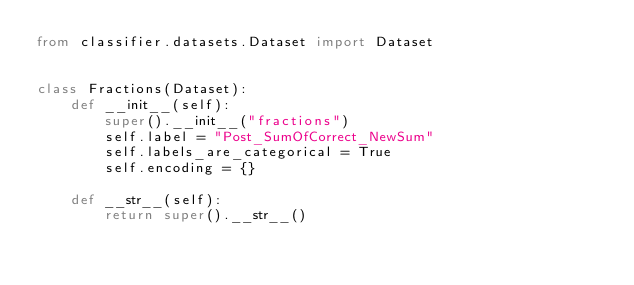<code> <loc_0><loc_0><loc_500><loc_500><_Python_>from classifier.datasets.Dataset import Dataset


class Fractions(Dataset):
    def __init__(self):
        super().__init__("fractions")
        self.label = "Post_SumOfCorrect_NewSum"
        self.labels_are_categorical = True
        self.encoding = {}

    def __str__(self):
        return super().__str__()
</code> 